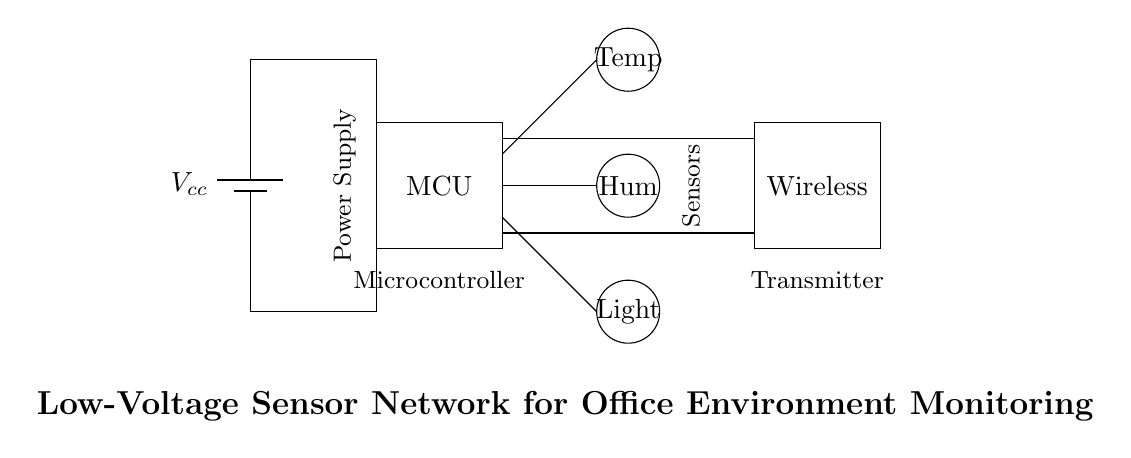What is the power supply used in the circuit? The circuit diagram shows a battery labeled as Vcc, indicating that the power supply is a battery.
Answer: Battery How many sensors are present in the circuit? The circuit diagram displays three circular components labeled as Temp, Hum, and Light, which correspond to temperature, humidity, and light sensors respectively. Thus, there are three sensors.
Answer: Three What does MCU stand for in the diagram? The rectangular component labeled as MCU refers to the microcontroller, which is the central unit that processes data from the sensors and manages the wireless module.
Answer: Microcontroller Which components are connected directly to the wireless module? The connections from the microcontroller indicate that data lines from both the temperature sensor and the humidity sensor go directly to the wireless module. There are no direct connections from the light sensor to the wireless module.
Answer: Temperature and humidity sensors What type of circuit is represented here? The circuit primarily involves low-voltage sensors and a microcontroller for monitoring environmental conditions. It incorporates energy-efficient battery usage and wireless communication, which are characteristic of a low voltage sensor network.
Answer: Low-voltage sensor network 